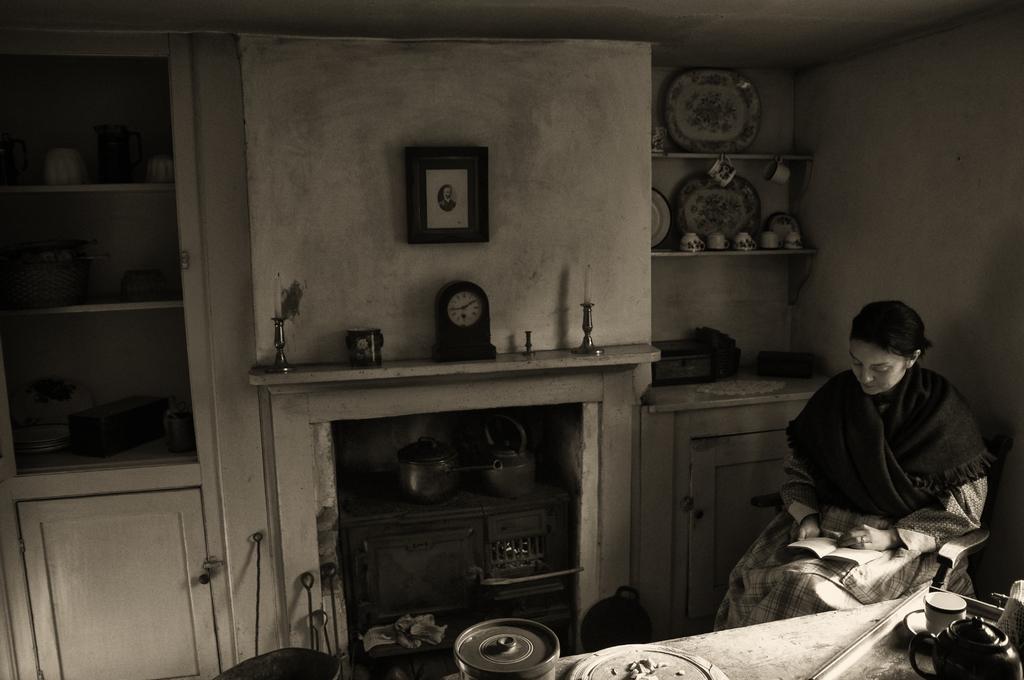How would you summarize this image in a sentence or two? In this image I can see a woman is sitting on the chair and holding book. I can see cups,jar and few objects on the table. Back I can see a cupboard,racks,watch and candles. The frame is attached to the wall. I can see few vessels in the cupboard. 